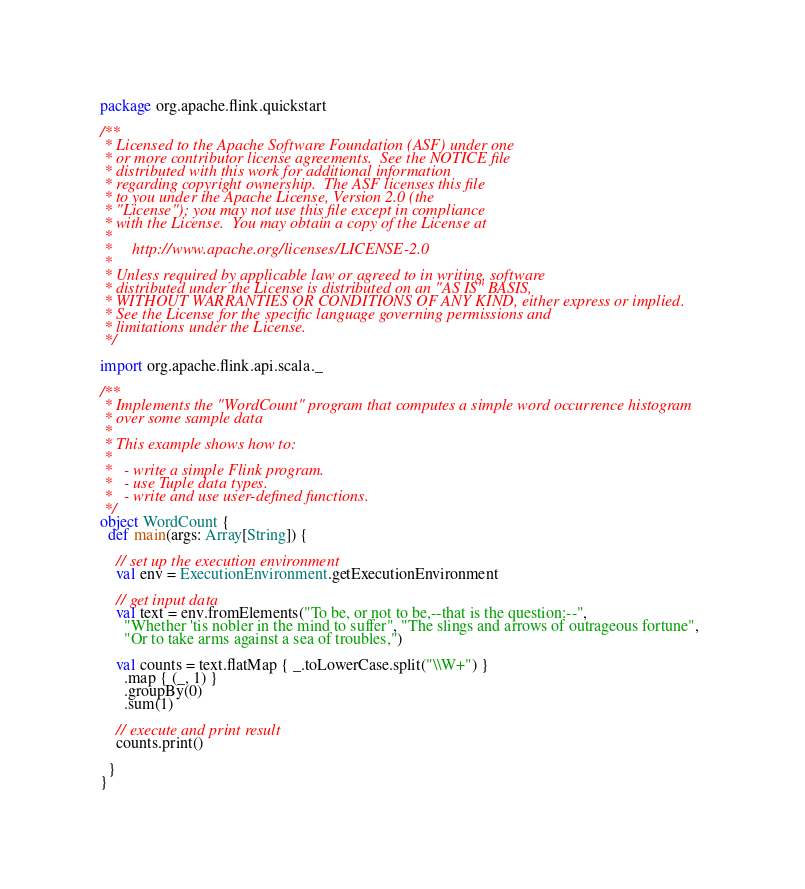Convert code to text. <code><loc_0><loc_0><loc_500><loc_500><_Scala_>package org.apache.flink.quickstart

/**
 * Licensed to the Apache Software Foundation (ASF) under one
 * or more contributor license agreements.  See the NOTICE file
 * distributed with this work for additional information
 * regarding copyright ownership.  The ASF licenses this file
 * to you under the Apache License, Version 2.0 (the
 * "License"); you may not use this file except in compliance
 * with the License.  You may obtain a copy of the License at
 *
 *     http://www.apache.org/licenses/LICENSE-2.0
 *
 * Unless required by applicable law or agreed to in writing, software
 * distributed under the License is distributed on an "AS IS" BASIS,
 * WITHOUT WARRANTIES OR CONDITIONS OF ANY KIND, either express or implied.
 * See the License for the specific language governing permissions and
 * limitations under the License.
 */

import org.apache.flink.api.scala._

/**
 * Implements the "WordCount" program that computes a simple word occurrence histogram
 * over some sample data
 *
 * This example shows how to:
 *
 *   - write a simple Flink program.
 *   - use Tuple data types.
 *   - write and use user-defined functions.
 */
object WordCount {
  def main(args: Array[String]) {

    // set up the execution environment
    val env = ExecutionEnvironment.getExecutionEnvironment

    // get input data
    val text = env.fromElements("To be, or not to be,--that is the question:--",
      "Whether 'tis nobler in the mind to suffer", "The slings and arrows of outrageous fortune",
      "Or to take arms against a sea of troubles,")

    val counts = text.flatMap { _.toLowerCase.split("\\W+") }
      .map { (_, 1) }
      .groupBy(0)
      .sum(1)

    // execute and print result
    counts.print()

  }
}
</code> 